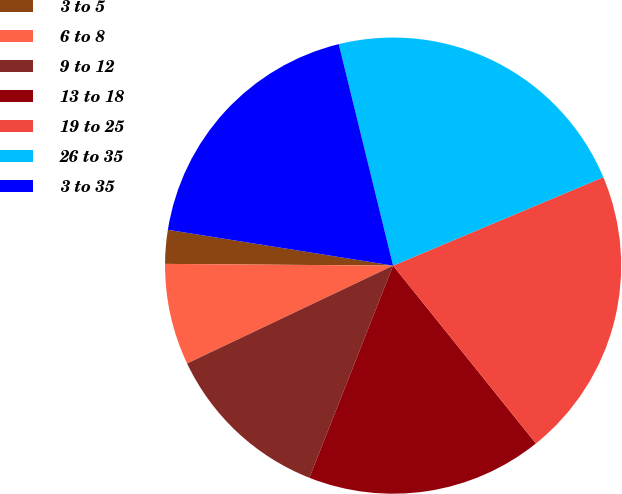Convert chart. <chart><loc_0><loc_0><loc_500><loc_500><pie_chart><fcel>3 to 5<fcel>6 to 8<fcel>9 to 12<fcel>13 to 18<fcel>19 to 25<fcel>26 to 35<fcel>3 to 35<nl><fcel>2.39%<fcel>7.18%<fcel>11.96%<fcel>16.75%<fcel>20.57%<fcel>22.49%<fcel>18.66%<nl></chart> 